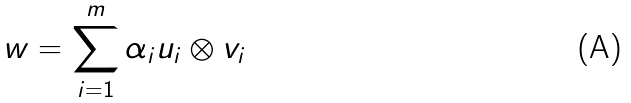<formula> <loc_0><loc_0><loc_500><loc_500>w = \sum _ { i = 1 } ^ { m } \alpha _ { i } u _ { i } \otimes v _ { i }</formula> 